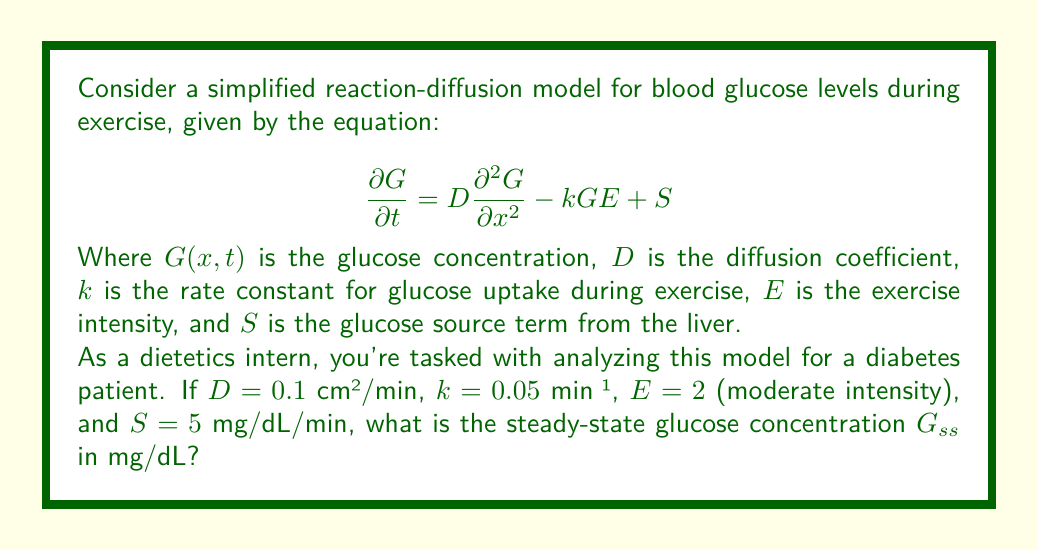What is the answer to this math problem? To solve this problem, we need to understand the concept of steady-state in a reaction-diffusion equation. At steady-state, the glucose concentration doesn't change with time, so $\frac{\partial G}{\partial t} = 0$.

Let's approach this step-by-step:

1) At steady-state, our equation becomes:

   $$0 = D\frac{\partial^2 G}{\partial x^2} - kGE + S$$

2) In a uniform steady-state, there's no spatial variation, so $\frac{\partial^2 G}{\partial x^2} = 0$. Our equation simplifies to:

   $$0 = -kG_{ss}E + S$$

3) Rearranging to solve for $G_{ss}$:

   $$kG_{ss}E = S$$
   $$G_{ss} = \frac{S}{kE}$$

4) Now, let's substitute our given values:
   
   $k = 0.05$ min⁻¹
   $E = 2$ (moderate intensity)
   $S = 5$ mg/dL/min

5) Calculating $G_{ss}$:

   $$G_{ss} = \frac{5}{0.05 \times 2} = \frac{5}{0.1} = 50$$

Therefore, the steady-state glucose concentration is 50 mg/dL.

This result is particularly relevant for diabetes management. A steady-state glucose level of 50 mg/dL during moderate exercise indicates that the patient's glucose uptake due to exercise is balanced by the liver's glucose production. However, this level is quite low and could potentially lead to hypoglycemia. As a dietetics intern, you would need to work with your mentor to develop strategies to maintain safer glucose levels during exercise for this patient.
Answer: $G_{ss} = 50$ mg/dL 